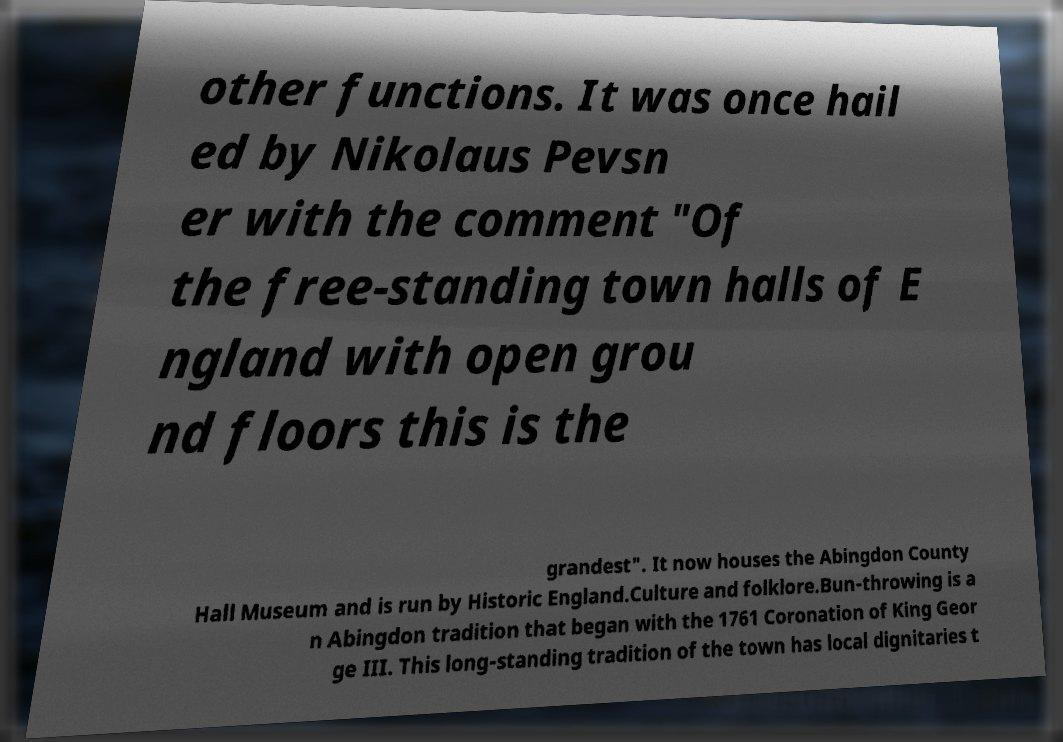Please identify and transcribe the text found in this image. other functions. It was once hail ed by Nikolaus Pevsn er with the comment "Of the free-standing town halls of E ngland with open grou nd floors this is the grandest". It now houses the Abingdon County Hall Museum and is run by Historic England.Culture and folklore.Bun-throwing is a n Abingdon tradition that began with the 1761 Coronation of King Geor ge III. This long-standing tradition of the town has local dignitaries t 